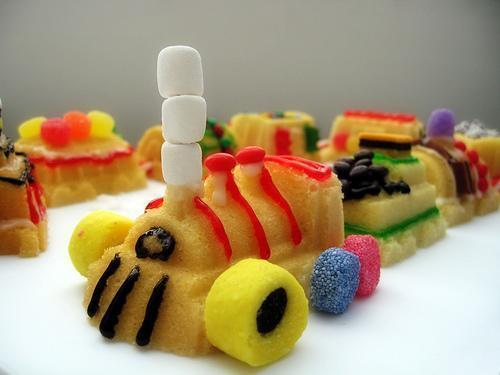How many marshmallows are here?
Give a very brief answer. 3. How many cakes are in the picture?
Give a very brief answer. 4. How many umbrellas are there?
Give a very brief answer. 0. 